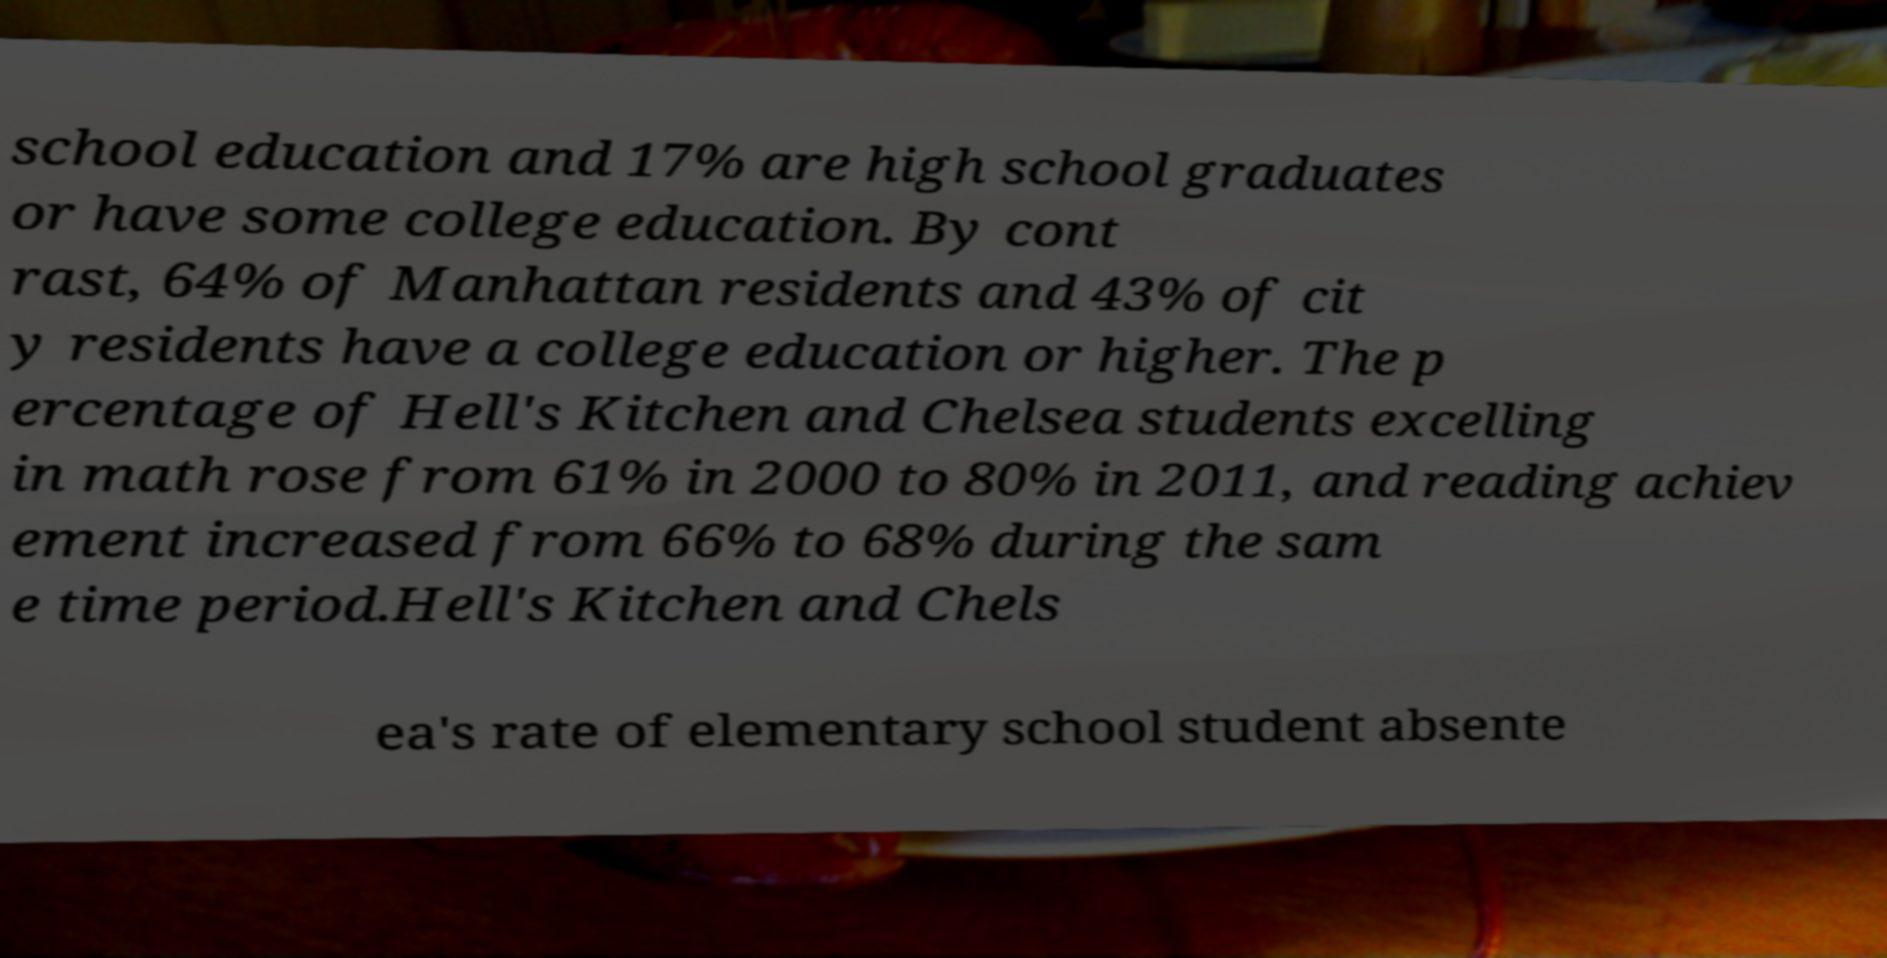There's text embedded in this image that I need extracted. Can you transcribe it verbatim? school education and 17% are high school graduates or have some college education. By cont rast, 64% of Manhattan residents and 43% of cit y residents have a college education or higher. The p ercentage of Hell's Kitchen and Chelsea students excelling in math rose from 61% in 2000 to 80% in 2011, and reading achiev ement increased from 66% to 68% during the sam e time period.Hell's Kitchen and Chels ea's rate of elementary school student absente 